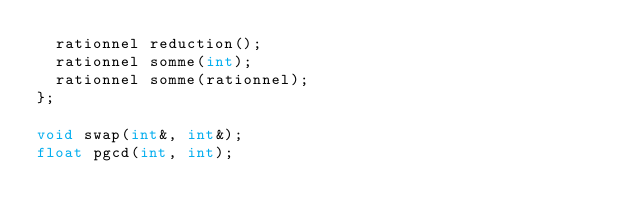Convert code to text. <code><loc_0><loc_0><loc_500><loc_500><_C_>	rationnel reduction(); 
	rationnel somme(int); 
	rationnel somme(rationnel);  
};

void swap(int&, int&);
float pgcd(int, int);

</code> 